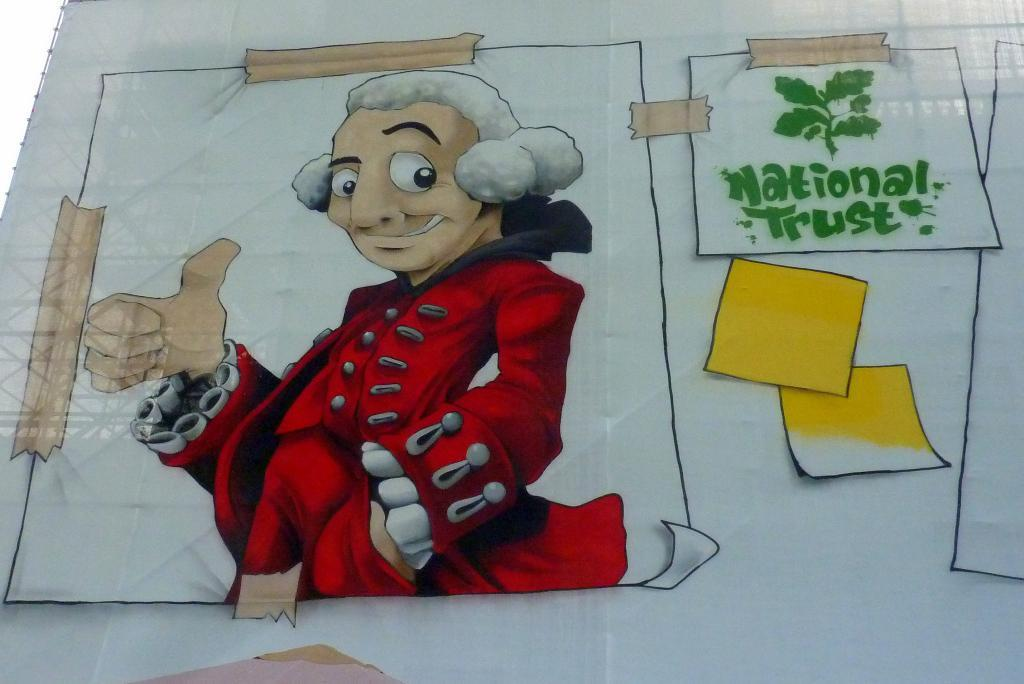<image>
Provide a brief description of the given image. A poster of a historical character relating to National Trust. 